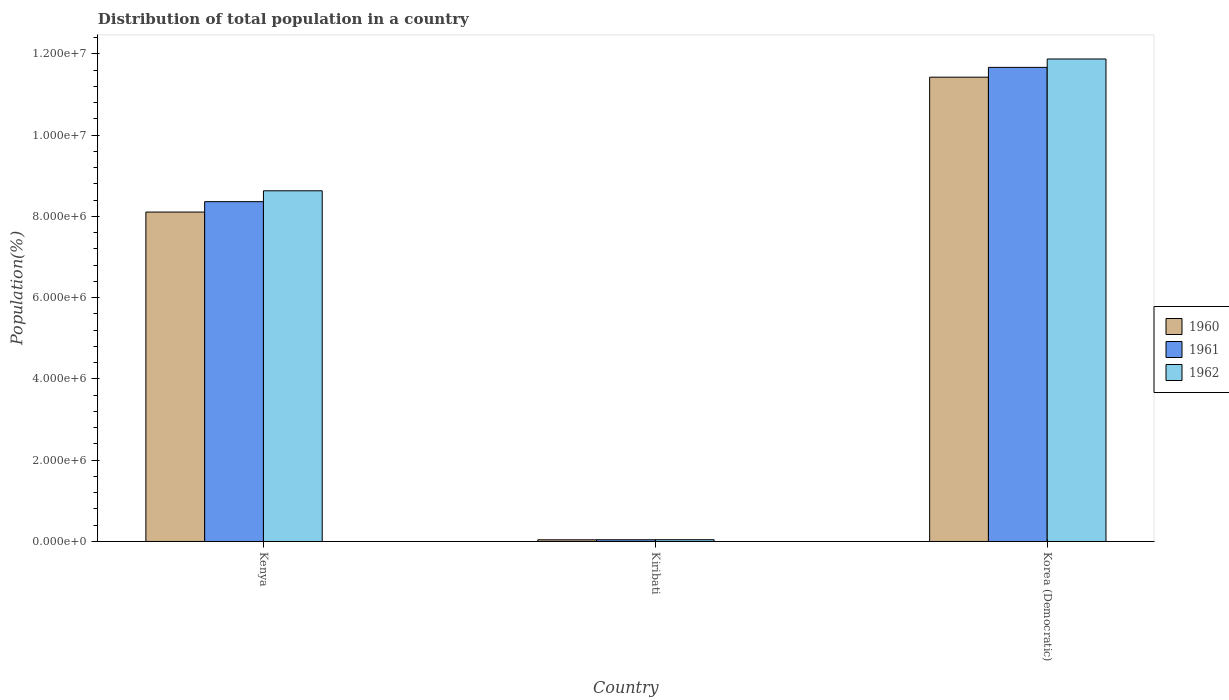How many different coloured bars are there?
Your answer should be very brief. 3. How many bars are there on the 3rd tick from the right?
Give a very brief answer. 3. What is the label of the 3rd group of bars from the left?
Ensure brevity in your answer.  Korea (Democratic). What is the population of in 1962 in Korea (Democratic)?
Your response must be concise. 1.19e+07. Across all countries, what is the maximum population of in 1961?
Give a very brief answer. 1.17e+07. Across all countries, what is the minimum population of in 1960?
Your response must be concise. 4.12e+04. In which country was the population of in 1962 maximum?
Make the answer very short. Korea (Democratic). In which country was the population of in 1962 minimum?
Give a very brief answer. Kiribati. What is the total population of in 1960 in the graph?
Provide a succinct answer. 1.96e+07. What is the difference between the population of in 1961 in Kenya and that in Kiribati?
Offer a very short reply. 8.32e+06. What is the difference between the population of in 1960 in Kiribati and the population of in 1961 in Kenya?
Your answer should be very brief. -8.32e+06. What is the average population of in 1960 per country?
Ensure brevity in your answer.  6.52e+06. What is the difference between the population of of/in 1960 and population of of/in 1961 in Korea (Democratic)?
Your answer should be very brief. -2.41e+05. What is the ratio of the population of in 1960 in Kenya to that in Kiribati?
Your answer should be very brief. 196.57. Is the population of in 1962 in Kiribati less than that in Korea (Democratic)?
Provide a short and direct response. Yes. What is the difference between the highest and the second highest population of in 1961?
Provide a short and direct response. 3.30e+06. What is the difference between the highest and the lowest population of in 1962?
Keep it short and to the point. 1.18e+07. What does the 1st bar from the right in Kiribati represents?
Provide a short and direct response. 1962. Are all the bars in the graph horizontal?
Provide a short and direct response. No. How many countries are there in the graph?
Make the answer very short. 3. Does the graph contain any zero values?
Offer a terse response. No. Does the graph contain grids?
Ensure brevity in your answer.  No. How many legend labels are there?
Ensure brevity in your answer.  3. What is the title of the graph?
Your response must be concise. Distribution of total population in a country. What is the label or title of the Y-axis?
Provide a short and direct response. Population(%). What is the Population(%) of 1960 in Kenya?
Your answer should be very brief. 8.11e+06. What is the Population(%) of 1961 in Kenya?
Ensure brevity in your answer.  8.36e+06. What is the Population(%) of 1962 in Kenya?
Your answer should be compact. 8.63e+06. What is the Population(%) of 1960 in Kiribati?
Give a very brief answer. 4.12e+04. What is the Population(%) of 1961 in Kiribati?
Offer a very short reply. 4.23e+04. What is the Population(%) in 1962 in Kiribati?
Give a very brief answer. 4.33e+04. What is the Population(%) in 1960 in Korea (Democratic)?
Provide a succinct answer. 1.14e+07. What is the Population(%) of 1961 in Korea (Democratic)?
Your answer should be compact. 1.17e+07. What is the Population(%) of 1962 in Korea (Democratic)?
Your answer should be compact. 1.19e+07. Across all countries, what is the maximum Population(%) in 1960?
Your answer should be compact. 1.14e+07. Across all countries, what is the maximum Population(%) in 1961?
Provide a short and direct response. 1.17e+07. Across all countries, what is the maximum Population(%) in 1962?
Provide a succinct answer. 1.19e+07. Across all countries, what is the minimum Population(%) of 1960?
Offer a terse response. 4.12e+04. Across all countries, what is the minimum Population(%) in 1961?
Make the answer very short. 4.23e+04. Across all countries, what is the minimum Population(%) in 1962?
Ensure brevity in your answer.  4.33e+04. What is the total Population(%) of 1960 in the graph?
Your response must be concise. 1.96e+07. What is the total Population(%) of 1961 in the graph?
Give a very brief answer. 2.01e+07. What is the total Population(%) in 1962 in the graph?
Give a very brief answer. 2.05e+07. What is the difference between the Population(%) of 1960 in Kenya and that in Kiribati?
Provide a short and direct response. 8.06e+06. What is the difference between the Population(%) in 1961 in Kenya and that in Kiribati?
Your answer should be very brief. 8.32e+06. What is the difference between the Population(%) of 1962 in Kenya and that in Kiribati?
Offer a very short reply. 8.59e+06. What is the difference between the Population(%) of 1960 in Kenya and that in Korea (Democratic)?
Your answer should be compact. -3.32e+06. What is the difference between the Population(%) in 1961 in Kenya and that in Korea (Democratic)?
Your answer should be very brief. -3.30e+06. What is the difference between the Population(%) of 1962 in Kenya and that in Korea (Democratic)?
Make the answer very short. -3.24e+06. What is the difference between the Population(%) of 1960 in Kiribati and that in Korea (Democratic)?
Your response must be concise. -1.14e+07. What is the difference between the Population(%) in 1961 in Kiribati and that in Korea (Democratic)?
Ensure brevity in your answer.  -1.16e+07. What is the difference between the Population(%) in 1962 in Kiribati and that in Korea (Democratic)?
Make the answer very short. -1.18e+07. What is the difference between the Population(%) in 1960 in Kenya and the Population(%) in 1961 in Kiribati?
Your answer should be compact. 8.06e+06. What is the difference between the Population(%) in 1960 in Kenya and the Population(%) in 1962 in Kiribati?
Provide a succinct answer. 8.06e+06. What is the difference between the Population(%) in 1961 in Kenya and the Population(%) in 1962 in Kiribati?
Offer a terse response. 8.32e+06. What is the difference between the Population(%) of 1960 in Kenya and the Population(%) of 1961 in Korea (Democratic)?
Keep it short and to the point. -3.56e+06. What is the difference between the Population(%) of 1960 in Kenya and the Population(%) of 1962 in Korea (Democratic)?
Keep it short and to the point. -3.77e+06. What is the difference between the Population(%) of 1961 in Kenya and the Population(%) of 1962 in Korea (Democratic)?
Keep it short and to the point. -3.51e+06. What is the difference between the Population(%) of 1960 in Kiribati and the Population(%) of 1961 in Korea (Democratic)?
Offer a very short reply. -1.16e+07. What is the difference between the Population(%) in 1960 in Kiribati and the Population(%) in 1962 in Korea (Democratic)?
Your answer should be compact. -1.18e+07. What is the difference between the Population(%) of 1961 in Kiribati and the Population(%) of 1962 in Korea (Democratic)?
Your answer should be compact. -1.18e+07. What is the average Population(%) in 1960 per country?
Your answer should be very brief. 6.52e+06. What is the average Population(%) in 1961 per country?
Offer a terse response. 6.69e+06. What is the average Population(%) in 1962 per country?
Provide a short and direct response. 6.85e+06. What is the difference between the Population(%) in 1960 and Population(%) in 1961 in Kenya?
Offer a very short reply. -2.56e+05. What is the difference between the Population(%) of 1960 and Population(%) of 1962 in Kenya?
Your response must be concise. -5.24e+05. What is the difference between the Population(%) of 1961 and Population(%) of 1962 in Kenya?
Provide a short and direct response. -2.68e+05. What is the difference between the Population(%) of 1960 and Population(%) of 1961 in Kiribati?
Provide a short and direct response. -1027. What is the difference between the Population(%) in 1960 and Population(%) in 1962 in Kiribati?
Your response must be concise. -2078. What is the difference between the Population(%) of 1961 and Population(%) of 1962 in Kiribati?
Your answer should be compact. -1051. What is the difference between the Population(%) of 1960 and Population(%) of 1961 in Korea (Democratic)?
Make the answer very short. -2.41e+05. What is the difference between the Population(%) of 1960 and Population(%) of 1962 in Korea (Democratic)?
Provide a short and direct response. -4.48e+05. What is the difference between the Population(%) of 1961 and Population(%) of 1962 in Korea (Democratic)?
Keep it short and to the point. -2.06e+05. What is the ratio of the Population(%) of 1960 in Kenya to that in Kiribati?
Your answer should be compact. 196.57. What is the ratio of the Population(%) in 1961 in Kenya to that in Kiribati?
Ensure brevity in your answer.  197.85. What is the ratio of the Population(%) in 1962 in Kenya to that in Kiribati?
Offer a very short reply. 199.23. What is the ratio of the Population(%) in 1960 in Kenya to that in Korea (Democratic)?
Offer a terse response. 0.71. What is the ratio of the Population(%) in 1961 in Kenya to that in Korea (Democratic)?
Provide a succinct answer. 0.72. What is the ratio of the Population(%) in 1962 in Kenya to that in Korea (Democratic)?
Your answer should be very brief. 0.73. What is the ratio of the Population(%) of 1960 in Kiribati to that in Korea (Democratic)?
Your answer should be very brief. 0. What is the ratio of the Population(%) of 1961 in Kiribati to that in Korea (Democratic)?
Ensure brevity in your answer.  0. What is the ratio of the Population(%) in 1962 in Kiribati to that in Korea (Democratic)?
Give a very brief answer. 0. What is the difference between the highest and the second highest Population(%) of 1960?
Offer a very short reply. 3.32e+06. What is the difference between the highest and the second highest Population(%) of 1961?
Ensure brevity in your answer.  3.30e+06. What is the difference between the highest and the second highest Population(%) of 1962?
Your answer should be compact. 3.24e+06. What is the difference between the highest and the lowest Population(%) in 1960?
Your answer should be compact. 1.14e+07. What is the difference between the highest and the lowest Population(%) of 1961?
Your answer should be compact. 1.16e+07. What is the difference between the highest and the lowest Population(%) in 1962?
Provide a succinct answer. 1.18e+07. 